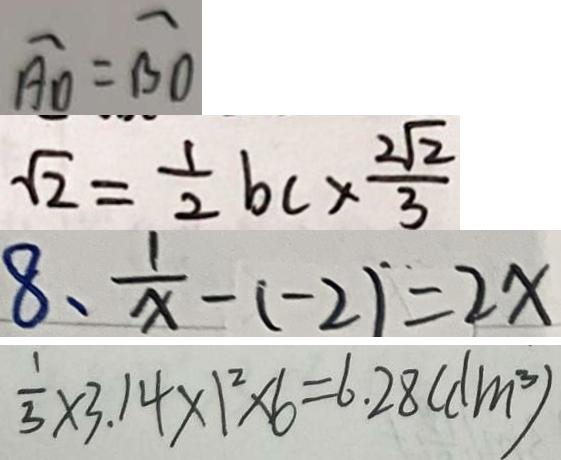Convert formula to latex. <formula><loc_0><loc_0><loc_500><loc_500>\widehat { A D } = \widehat { B O } 
 \sqrt { 2 } = \frac { 1 } { 2 } b c \times \frac { 2 \sqrt { 2 } } { 3 } 
 8 、 \frac { 1 } { x } - ( - 2 ) = 2 x 
 \frac { 1 } { 3 } \times 3 . 1 4 \times 1 ^ { 2 } \times 6 = 6 . 2 8 ( d m ^ { 3 } )</formula> 